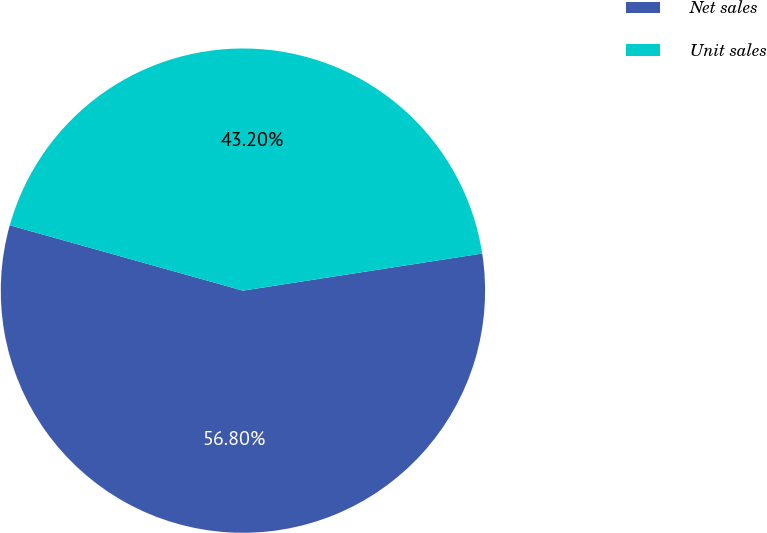<chart> <loc_0><loc_0><loc_500><loc_500><pie_chart><fcel>Net sales<fcel>Unit sales<nl><fcel>56.8%<fcel>43.2%<nl></chart> 